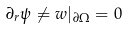<formula> <loc_0><loc_0><loc_500><loc_500>\partial _ { r } \psi \ne w | _ { \partial \Omega } = 0</formula> 